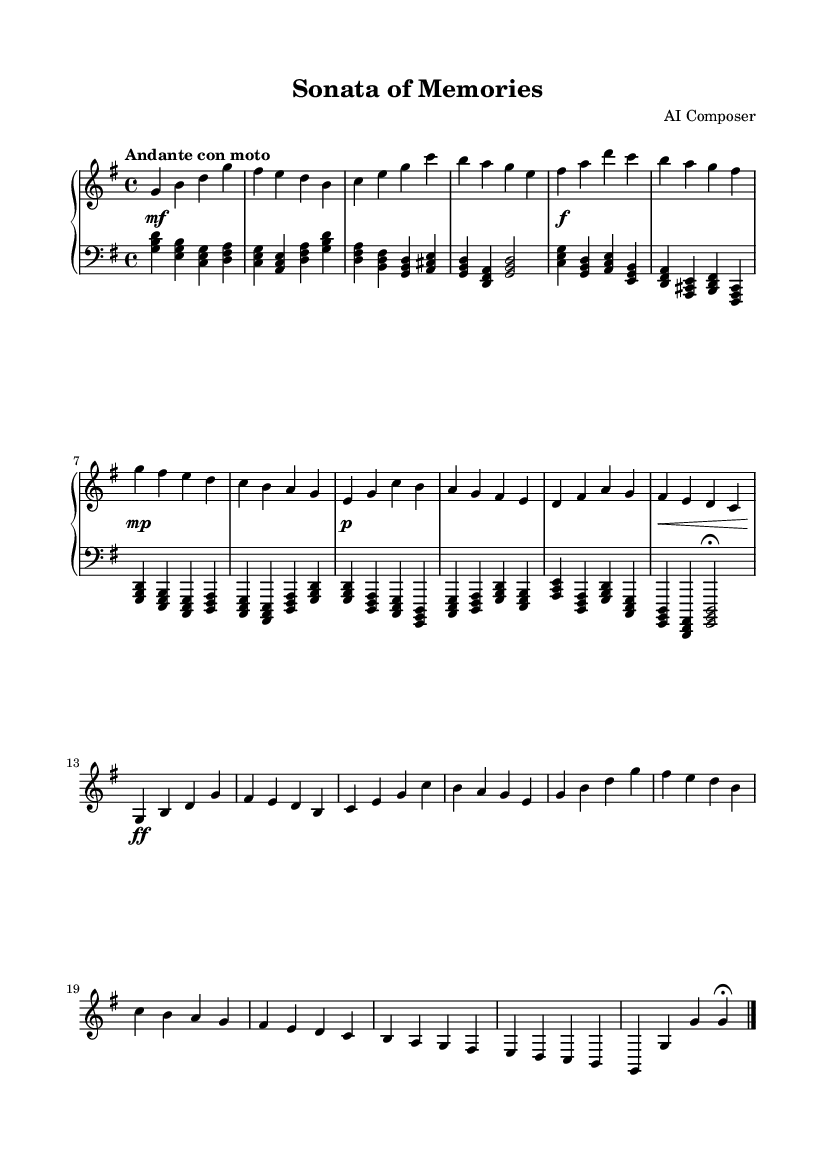What is the key signature of this music? The key signature is G major, which has one sharp (F#). You can determine this by looking at the key signature indication at the beginning of the staff.
Answer: G major What is the time signature of this music? The time signature is 4/4, which indicates four beats per measure. This can be found at the beginning of the score where the time signature is indicated.
Answer: 4/4 What is the tempo marking of this piece? The tempo marking is "Andante con moto," which suggests a walking speed with a bit of motion. This is located near the top of the score where tempo indications are usually provided.
Answer: Andante con moto How many measures are in the exposition section? The exposition section contains 8 measures. This can be counted by looking at the first part of the score, noting how many distinct groupings or bars there are before the development begins.
Answer: 8 What dynamics are featured at the beginning of this piece? The dynamics at the beginning are marked as mezzo-forte (mf). You can see this indication right at the start of the score before the music begins, showing the intended volume level.
Answer: mezzo-forte In which structural section does the recapitulation begin? The recapitulation begins after the development section, which is typically defined by a return of thematic material from the exposition. This can be determined by comparing the sections and identifying the thematic returns.
Answer: Recapitulation What is the final dynamic marking of the piece? The final dynamic marking is "fermata," indicating a pause at the end. This can be identified at the end of the score where it suggests slowing down before concluding.
Answer: fermata 